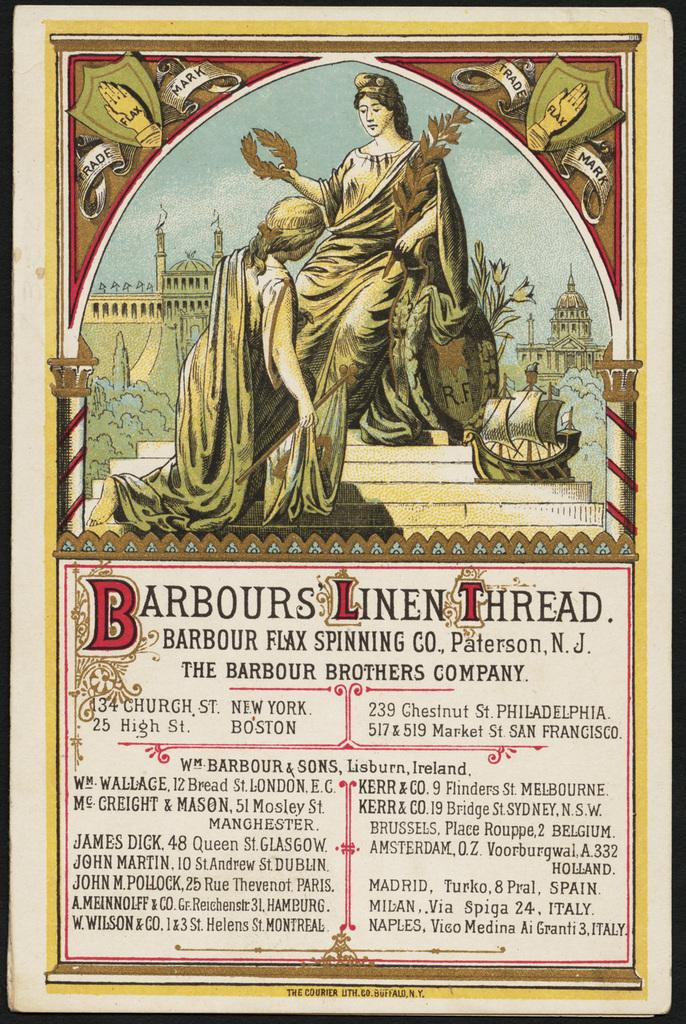<image>
Write a terse but informative summary of the picture. An old print image with a woman at the top and the words Barbours LInen Thread on it. 